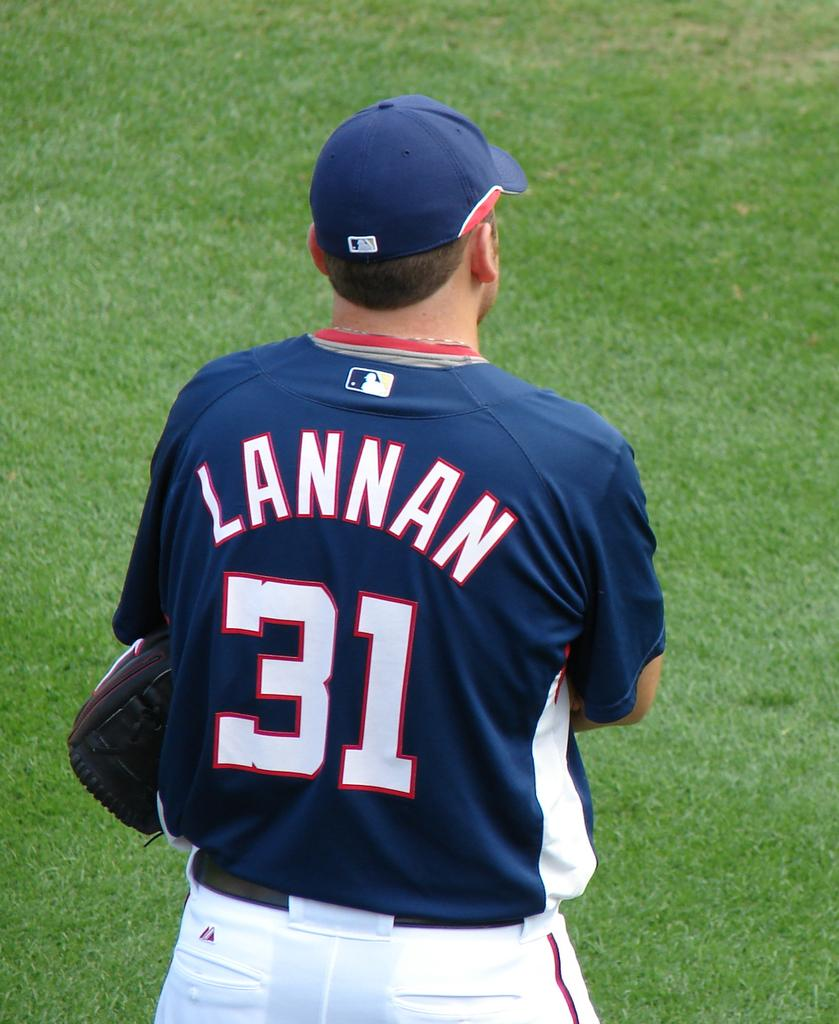<image>
Write a terse but informative summary of the picture. A baseball player stands on the field and his jersey says LANNAN 31 on the back 